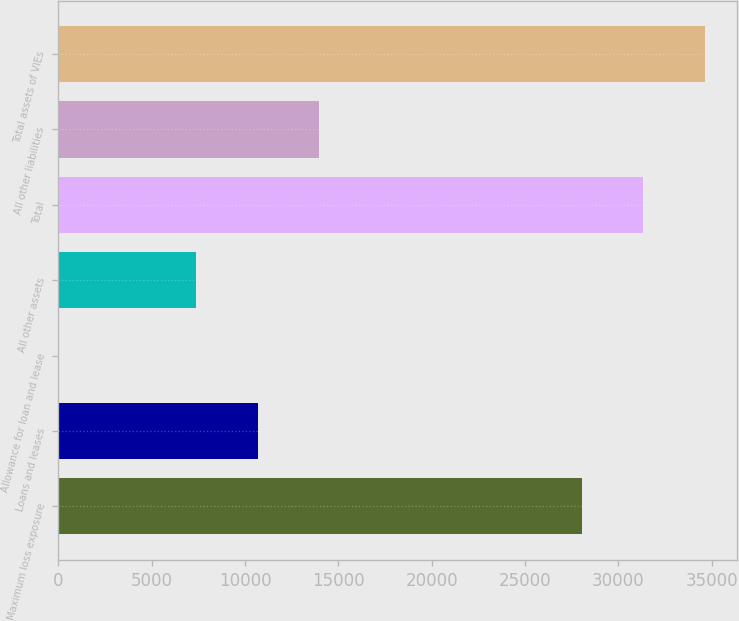<chart> <loc_0><loc_0><loc_500><loc_500><bar_chart><fcel>Maximum loss exposure<fcel>Loans and leases<fcel>Allowance for loan and lease<fcel>All other assets<fcel>Total<fcel>All other liabilities<fcel>Total assets of VIEs<nl><fcel>28044<fcel>10673.1<fcel>49<fcel>7377<fcel>31340.1<fcel>13969.2<fcel>34636.2<nl></chart> 